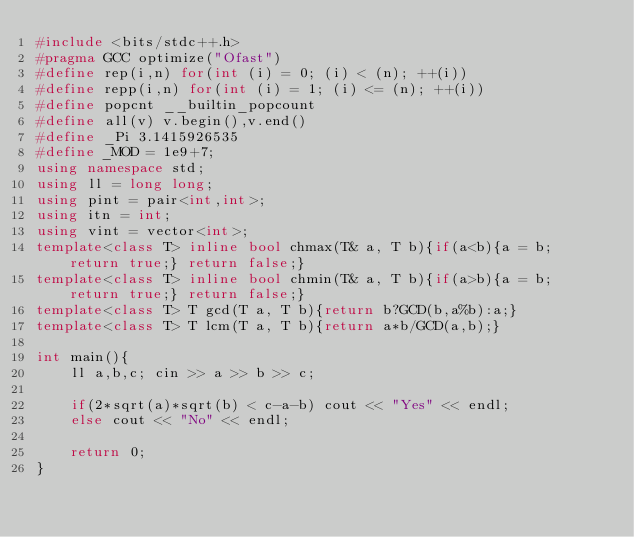<code> <loc_0><loc_0><loc_500><loc_500><_C++_>#include <bits/stdc++.h>
#pragma GCC optimize("Ofast")
#define rep(i,n) for(int (i) = 0; (i) < (n); ++(i))
#define repp(i,n) for(int (i) = 1; (i) <= (n); ++(i))
#define popcnt __builtin_popcount
#define all(v) v.begin(),v.end()
#define _Pi 3.1415926535
#define _MOD = 1e9+7;
using namespace std;
using ll = long long;
using pint = pair<int,int>;
using itn = int;
using vint = vector<int>;
template<class T> inline bool chmax(T& a, T b){if(a<b){a = b; return true;} return false;}
template<class T> inline bool chmin(T& a, T b){if(a>b){a = b; return true;} return false;}
template<class T> T gcd(T a, T b){return b?GCD(b,a%b):a;}
template<class T> T lcm(T a, T b){return a*b/GCD(a,b);}

int main(){
    ll a,b,c; cin >> a >> b >> c;

    if(2*sqrt(a)*sqrt(b) < c-a-b) cout << "Yes" << endl;
    else cout << "No" << endl;
    
    return 0;
}
</code> 